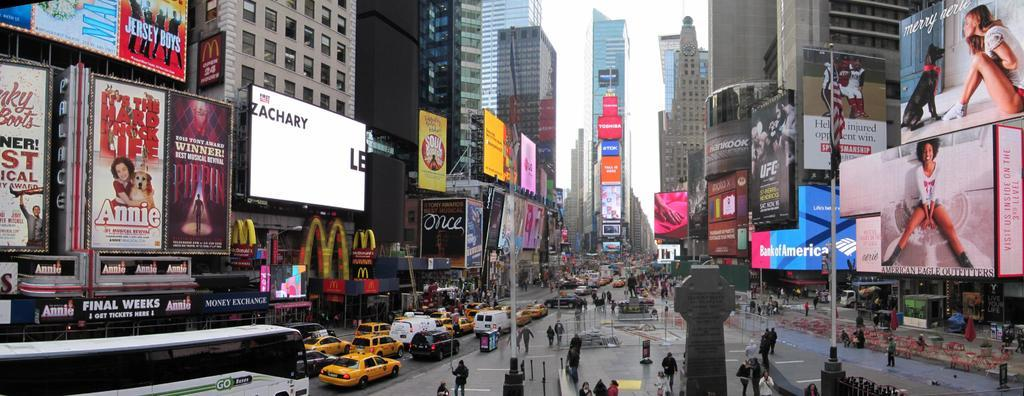<image>
Offer a succinct explanation of the picture presented. A busy street filled with large advertisements for the movie Annie. 